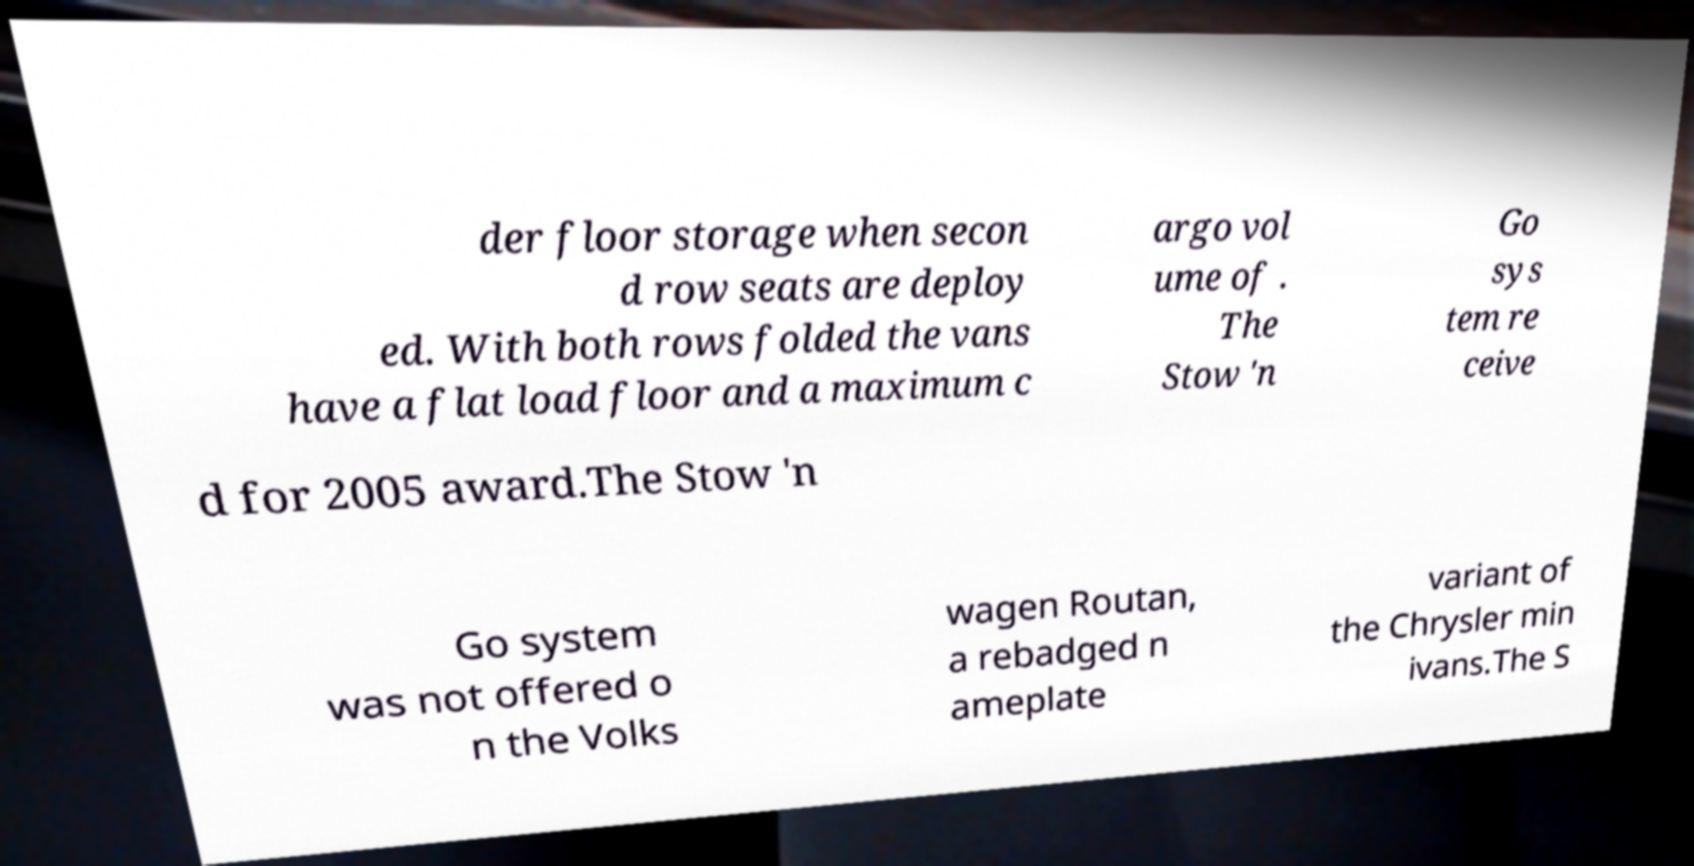I need the written content from this picture converted into text. Can you do that? der floor storage when secon d row seats are deploy ed. With both rows folded the vans have a flat load floor and a maximum c argo vol ume of . The Stow 'n Go sys tem re ceive d for 2005 award.The Stow 'n Go system was not offered o n the Volks wagen Routan, a rebadged n ameplate variant of the Chrysler min ivans.The S 